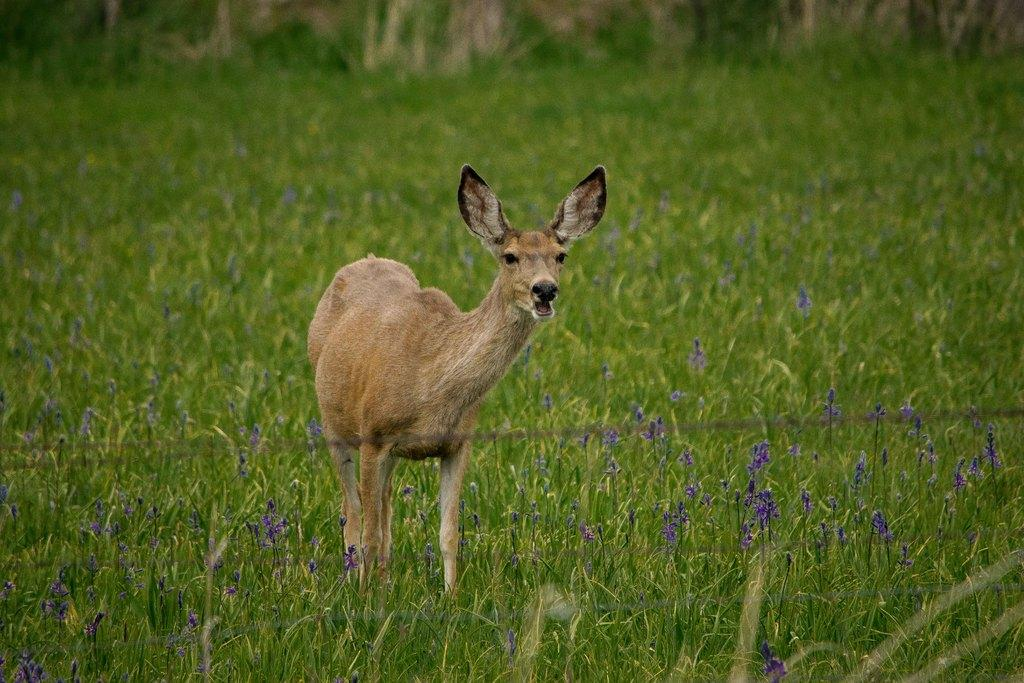What animal is present in the image? There is a deer in the image. Where is the deer located? The deer is on a grassland. Can you describe the background of the image? The background of the image is blurred. How many ducks are swimming in the wave in the image? There are no ducks or waves present in the image; it features a deer on a grassland with a blurred background. 